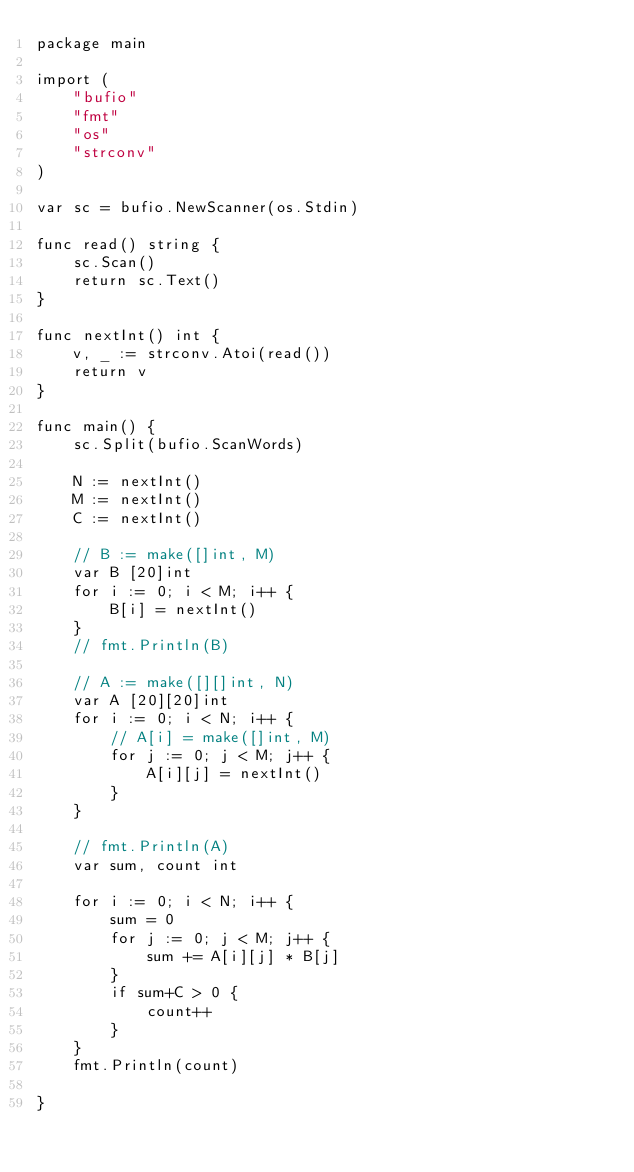Convert code to text. <code><loc_0><loc_0><loc_500><loc_500><_Go_>package main

import (
	"bufio"
	"fmt"
	"os"
	"strconv"
)

var sc = bufio.NewScanner(os.Stdin)

func read() string {
	sc.Scan()
	return sc.Text()
}

func nextInt() int {
	v, _ := strconv.Atoi(read())
	return v
}

func main() {
	sc.Split(bufio.ScanWords)

	N := nextInt()
	M := nextInt()
	C := nextInt()

	// B := make([]int, M)
	var B [20]int
	for i := 0; i < M; i++ {
		B[i] = nextInt()
	}
	// fmt.Println(B)

	// A := make([][]int, N)
	var A [20][20]int
	for i := 0; i < N; i++ {
		// A[i] = make([]int, M)
		for j := 0; j < M; j++ {
			A[i][j] = nextInt()
		}
	}

	// fmt.Println(A)
	var sum, count int

	for i := 0; i < N; i++ {
		sum = 0
		for j := 0; j < M; j++ {
			sum += A[i][j] * B[j]
		}
		if sum+C > 0 {
			count++
		}
	}
	fmt.Println(count)

}
</code> 